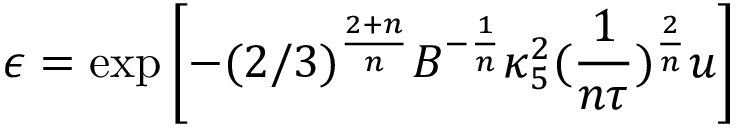Convert formula to latex. <formula><loc_0><loc_0><loc_500><loc_500>{ \epsilon = \exp \left [ - ( 2 / 3 ) ^ { \frac { 2 + n } { n } } B ^ { - \frac { 1 } { n } } \kappa _ { 5 } ^ { 2 } ( \frac { 1 } { n \tau } ) ^ { \frac { 2 } { n } } u \right ] }</formula> 